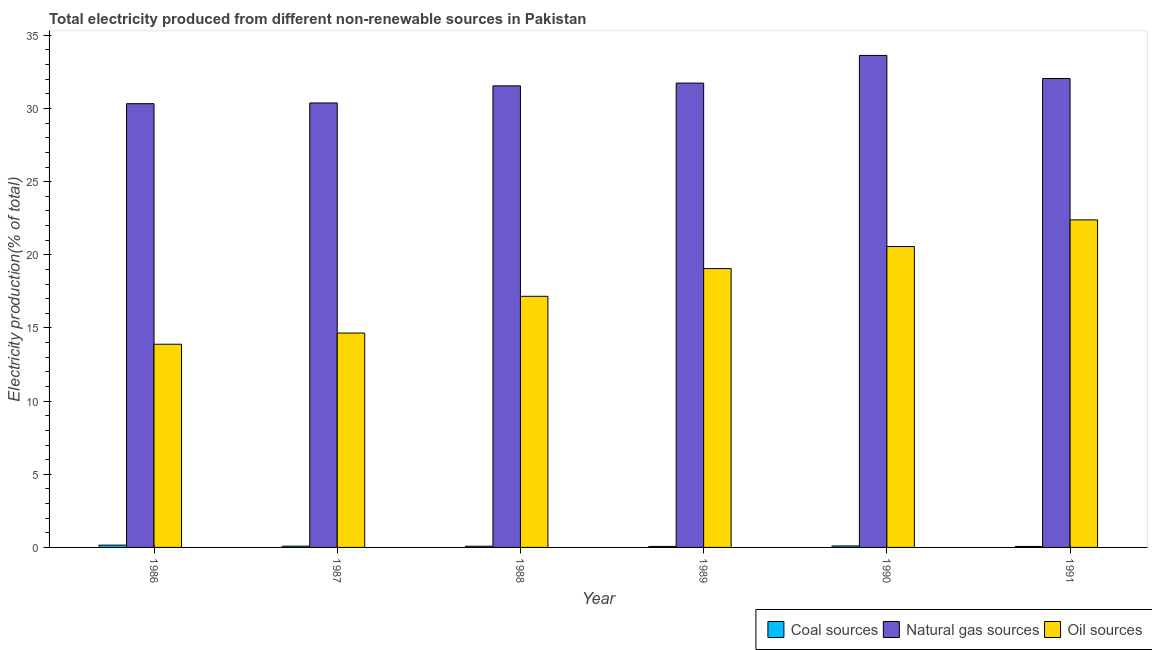How many bars are there on the 4th tick from the right?
Your answer should be compact. 3. What is the percentage of electricity produced by coal in 1988?
Your answer should be very brief. 0.08. Across all years, what is the maximum percentage of electricity produced by oil sources?
Your response must be concise. 22.39. Across all years, what is the minimum percentage of electricity produced by coal?
Your response must be concise. 0.07. In which year was the percentage of electricity produced by natural gas minimum?
Offer a very short reply. 1986. What is the total percentage of electricity produced by oil sources in the graph?
Offer a terse response. 107.72. What is the difference between the percentage of electricity produced by oil sources in 1986 and that in 1988?
Make the answer very short. -3.28. What is the difference between the percentage of electricity produced by coal in 1991 and the percentage of electricity produced by oil sources in 1990?
Offer a terse response. -0.04. What is the average percentage of electricity produced by oil sources per year?
Your answer should be compact. 17.95. What is the ratio of the percentage of electricity produced by natural gas in 1987 to that in 1988?
Provide a succinct answer. 0.96. What is the difference between the highest and the second highest percentage of electricity produced by coal?
Offer a terse response. 0.06. What is the difference between the highest and the lowest percentage of electricity produced by oil sources?
Your response must be concise. 8.5. In how many years, is the percentage of electricity produced by oil sources greater than the average percentage of electricity produced by oil sources taken over all years?
Keep it short and to the point. 3. What does the 2nd bar from the left in 1989 represents?
Provide a succinct answer. Natural gas sources. What does the 3rd bar from the right in 1989 represents?
Provide a succinct answer. Coal sources. How many bars are there?
Make the answer very short. 18. Are the values on the major ticks of Y-axis written in scientific E-notation?
Your response must be concise. No. Where does the legend appear in the graph?
Make the answer very short. Bottom right. What is the title of the graph?
Give a very brief answer. Total electricity produced from different non-renewable sources in Pakistan. What is the label or title of the Y-axis?
Offer a very short reply. Electricity production(% of total). What is the Electricity production(% of total) in Coal sources in 1986?
Your answer should be very brief. 0.16. What is the Electricity production(% of total) of Natural gas sources in 1986?
Provide a succinct answer. 30.33. What is the Electricity production(% of total) of Oil sources in 1986?
Offer a terse response. 13.89. What is the Electricity production(% of total) in Coal sources in 1987?
Your answer should be compact. 0.09. What is the Electricity production(% of total) in Natural gas sources in 1987?
Your answer should be compact. 30.38. What is the Electricity production(% of total) of Oil sources in 1987?
Ensure brevity in your answer.  14.65. What is the Electricity production(% of total) in Coal sources in 1988?
Offer a terse response. 0.08. What is the Electricity production(% of total) of Natural gas sources in 1988?
Your response must be concise. 31.55. What is the Electricity production(% of total) of Oil sources in 1988?
Your answer should be compact. 17.16. What is the Electricity production(% of total) in Coal sources in 1989?
Offer a very short reply. 0.07. What is the Electricity production(% of total) in Natural gas sources in 1989?
Ensure brevity in your answer.  31.74. What is the Electricity production(% of total) of Oil sources in 1989?
Keep it short and to the point. 19.06. What is the Electricity production(% of total) in Coal sources in 1990?
Make the answer very short. 0.1. What is the Electricity production(% of total) in Natural gas sources in 1990?
Keep it short and to the point. 33.63. What is the Electricity production(% of total) in Oil sources in 1990?
Make the answer very short. 20.57. What is the Electricity production(% of total) of Coal sources in 1991?
Your answer should be very brief. 0.07. What is the Electricity production(% of total) in Natural gas sources in 1991?
Offer a terse response. 32.05. What is the Electricity production(% of total) of Oil sources in 1991?
Offer a very short reply. 22.39. Across all years, what is the maximum Electricity production(% of total) in Coal sources?
Give a very brief answer. 0.16. Across all years, what is the maximum Electricity production(% of total) of Natural gas sources?
Provide a short and direct response. 33.63. Across all years, what is the maximum Electricity production(% of total) of Oil sources?
Your answer should be compact. 22.39. Across all years, what is the minimum Electricity production(% of total) in Coal sources?
Offer a very short reply. 0.07. Across all years, what is the minimum Electricity production(% of total) in Natural gas sources?
Offer a very short reply. 30.33. Across all years, what is the minimum Electricity production(% of total) of Oil sources?
Ensure brevity in your answer.  13.89. What is the total Electricity production(% of total) in Coal sources in the graph?
Provide a short and direct response. 0.56. What is the total Electricity production(% of total) in Natural gas sources in the graph?
Your response must be concise. 189.68. What is the total Electricity production(% of total) in Oil sources in the graph?
Your answer should be very brief. 107.72. What is the difference between the Electricity production(% of total) in Coal sources in 1986 and that in 1987?
Offer a terse response. 0.07. What is the difference between the Electricity production(% of total) of Natural gas sources in 1986 and that in 1987?
Your answer should be compact. -0.05. What is the difference between the Electricity production(% of total) of Oil sources in 1986 and that in 1987?
Make the answer very short. -0.76. What is the difference between the Electricity production(% of total) in Coal sources in 1986 and that in 1988?
Your response must be concise. 0.07. What is the difference between the Electricity production(% of total) in Natural gas sources in 1986 and that in 1988?
Your answer should be very brief. -1.22. What is the difference between the Electricity production(% of total) of Oil sources in 1986 and that in 1988?
Offer a very short reply. -3.28. What is the difference between the Electricity production(% of total) of Coal sources in 1986 and that in 1989?
Offer a very short reply. 0.09. What is the difference between the Electricity production(% of total) of Natural gas sources in 1986 and that in 1989?
Ensure brevity in your answer.  -1.41. What is the difference between the Electricity production(% of total) in Oil sources in 1986 and that in 1989?
Give a very brief answer. -5.17. What is the difference between the Electricity production(% of total) of Coal sources in 1986 and that in 1990?
Provide a succinct answer. 0.06. What is the difference between the Electricity production(% of total) in Natural gas sources in 1986 and that in 1990?
Provide a succinct answer. -3.3. What is the difference between the Electricity production(% of total) in Oil sources in 1986 and that in 1990?
Your answer should be compact. -6.68. What is the difference between the Electricity production(% of total) in Coal sources in 1986 and that in 1991?
Your answer should be compact. 0.09. What is the difference between the Electricity production(% of total) of Natural gas sources in 1986 and that in 1991?
Offer a terse response. -1.72. What is the difference between the Electricity production(% of total) in Oil sources in 1986 and that in 1991?
Give a very brief answer. -8.5. What is the difference between the Electricity production(% of total) in Coal sources in 1987 and that in 1988?
Ensure brevity in your answer.  0.01. What is the difference between the Electricity production(% of total) of Natural gas sources in 1987 and that in 1988?
Give a very brief answer. -1.17. What is the difference between the Electricity production(% of total) in Oil sources in 1987 and that in 1988?
Your answer should be compact. -2.51. What is the difference between the Electricity production(% of total) of Coal sources in 1987 and that in 1989?
Offer a very short reply. 0.02. What is the difference between the Electricity production(% of total) in Natural gas sources in 1987 and that in 1989?
Keep it short and to the point. -1.36. What is the difference between the Electricity production(% of total) of Oil sources in 1987 and that in 1989?
Keep it short and to the point. -4.41. What is the difference between the Electricity production(% of total) in Coal sources in 1987 and that in 1990?
Provide a succinct answer. -0.01. What is the difference between the Electricity production(% of total) in Natural gas sources in 1987 and that in 1990?
Ensure brevity in your answer.  -3.25. What is the difference between the Electricity production(% of total) in Oil sources in 1987 and that in 1990?
Provide a succinct answer. -5.91. What is the difference between the Electricity production(% of total) in Coal sources in 1987 and that in 1991?
Give a very brief answer. 0.02. What is the difference between the Electricity production(% of total) of Natural gas sources in 1987 and that in 1991?
Offer a terse response. -1.67. What is the difference between the Electricity production(% of total) in Oil sources in 1987 and that in 1991?
Provide a short and direct response. -7.73. What is the difference between the Electricity production(% of total) in Coal sources in 1988 and that in 1989?
Offer a very short reply. 0.01. What is the difference between the Electricity production(% of total) of Natural gas sources in 1988 and that in 1989?
Your answer should be compact. -0.19. What is the difference between the Electricity production(% of total) of Oil sources in 1988 and that in 1989?
Your answer should be very brief. -1.9. What is the difference between the Electricity production(% of total) in Coal sources in 1988 and that in 1990?
Offer a terse response. -0.02. What is the difference between the Electricity production(% of total) in Natural gas sources in 1988 and that in 1990?
Provide a succinct answer. -2.08. What is the difference between the Electricity production(% of total) in Oil sources in 1988 and that in 1990?
Keep it short and to the point. -3.4. What is the difference between the Electricity production(% of total) in Coal sources in 1988 and that in 1991?
Make the answer very short. 0.02. What is the difference between the Electricity production(% of total) of Natural gas sources in 1988 and that in 1991?
Provide a short and direct response. -0.5. What is the difference between the Electricity production(% of total) of Oil sources in 1988 and that in 1991?
Offer a very short reply. -5.22. What is the difference between the Electricity production(% of total) in Coal sources in 1989 and that in 1990?
Ensure brevity in your answer.  -0.03. What is the difference between the Electricity production(% of total) in Natural gas sources in 1989 and that in 1990?
Offer a very short reply. -1.89. What is the difference between the Electricity production(% of total) of Oil sources in 1989 and that in 1990?
Keep it short and to the point. -1.51. What is the difference between the Electricity production(% of total) in Coal sources in 1989 and that in 1991?
Provide a succinct answer. 0. What is the difference between the Electricity production(% of total) in Natural gas sources in 1989 and that in 1991?
Offer a very short reply. -0.31. What is the difference between the Electricity production(% of total) in Oil sources in 1989 and that in 1991?
Keep it short and to the point. -3.33. What is the difference between the Electricity production(% of total) in Coal sources in 1990 and that in 1991?
Make the answer very short. 0.04. What is the difference between the Electricity production(% of total) in Natural gas sources in 1990 and that in 1991?
Keep it short and to the point. 1.58. What is the difference between the Electricity production(% of total) of Oil sources in 1990 and that in 1991?
Your response must be concise. -1.82. What is the difference between the Electricity production(% of total) in Coal sources in 1986 and the Electricity production(% of total) in Natural gas sources in 1987?
Your answer should be very brief. -30.22. What is the difference between the Electricity production(% of total) in Coal sources in 1986 and the Electricity production(% of total) in Oil sources in 1987?
Give a very brief answer. -14.5. What is the difference between the Electricity production(% of total) in Natural gas sources in 1986 and the Electricity production(% of total) in Oil sources in 1987?
Keep it short and to the point. 15.68. What is the difference between the Electricity production(% of total) in Coal sources in 1986 and the Electricity production(% of total) in Natural gas sources in 1988?
Your answer should be very brief. -31.39. What is the difference between the Electricity production(% of total) of Coal sources in 1986 and the Electricity production(% of total) of Oil sources in 1988?
Ensure brevity in your answer.  -17.01. What is the difference between the Electricity production(% of total) of Natural gas sources in 1986 and the Electricity production(% of total) of Oil sources in 1988?
Provide a succinct answer. 13.16. What is the difference between the Electricity production(% of total) of Coal sources in 1986 and the Electricity production(% of total) of Natural gas sources in 1989?
Your answer should be very brief. -31.58. What is the difference between the Electricity production(% of total) in Coal sources in 1986 and the Electricity production(% of total) in Oil sources in 1989?
Your response must be concise. -18.9. What is the difference between the Electricity production(% of total) of Natural gas sources in 1986 and the Electricity production(% of total) of Oil sources in 1989?
Ensure brevity in your answer.  11.27. What is the difference between the Electricity production(% of total) in Coal sources in 1986 and the Electricity production(% of total) in Natural gas sources in 1990?
Your answer should be compact. -33.47. What is the difference between the Electricity production(% of total) in Coal sources in 1986 and the Electricity production(% of total) in Oil sources in 1990?
Give a very brief answer. -20.41. What is the difference between the Electricity production(% of total) in Natural gas sources in 1986 and the Electricity production(% of total) in Oil sources in 1990?
Keep it short and to the point. 9.76. What is the difference between the Electricity production(% of total) in Coal sources in 1986 and the Electricity production(% of total) in Natural gas sources in 1991?
Keep it short and to the point. -31.89. What is the difference between the Electricity production(% of total) of Coal sources in 1986 and the Electricity production(% of total) of Oil sources in 1991?
Provide a succinct answer. -22.23. What is the difference between the Electricity production(% of total) in Natural gas sources in 1986 and the Electricity production(% of total) in Oil sources in 1991?
Keep it short and to the point. 7.94. What is the difference between the Electricity production(% of total) in Coal sources in 1987 and the Electricity production(% of total) in Natural gas sources in 1988?
Your answer should be compact. -31.46. What is the difference between the Electricity production(% of total) in Coal sources in 1987 and the Electricity production(% of total) in Oil sources in 1988?
Provide a short and direct response. -17.08. What is the difference between the Electricity production(% of total) in Natural gas sources in 1987 and the Electricity production(% of total) in Oil sources in 1988?
Keep it short and to the point. 13.22. What is the difference between the Electricity production(% of total) of Coal sources in 1987 and the Electricity production(% of total) of Natural gas sources in 1989?
Provide a succinct answer. -31.65. What is the difference between the Electricity production(% of total) in Coal sources in 1987 and the Electricity production(% of total) in Oil sources in 1989?
Your response must be concise. -18.97. What is the difference between the Electricity production(% of total) in Natural gas sources in 1987 and the Electricity production(% of total) in Oil sources in 1989?
Provide a succinct answer. 11.32. What is the difference between the Electricity production(% of total) in Coal sources in 1987 and the Electricity production(% of total) in Natural gas sources in 1990?
Provide a short and direct response. -33.54. What is the difference between the Electricity production(% of total) of Coal sources in 1987 and the Electricity production(% of total) of Oil sources in 1990?
Offer a very short reply. -20.48. What is the difference between the Electricity production(% of total) in Natural gas sources in 1987 and the Electricity production(% of total) in Oil sources in 1990?
Offer a terse response. 9.81. What is the difference between the Electricity production(% of total) of Coal sources in 1987 and the Electricity production(% of total) of Natural gas sources in 1991?
Offer a terse response. -31.96. What is the difference between the Electricity production(% of total) in Coal sources in 1987 and the Electricity production(% of total) in Oil sources in 1991?
Make the answer very short. -22.3. What is the difference between the Electricity production(% of total) of Natural gas sources in 1987 and the Electricity production(% of total) of Oil sources in 1991?
Offer a very short reply. 7.99. What is the difference between the Electricity production(% of total) in Coal sources in 1988 and the Electricity production(% of total) in Natural gas sources in 1989?
Your answer should be very brief. -31.66. What is the difference between the Electricity production(% of total) of Coal sources in 1988 and the Electricity production(% of total) of Oil sources in 1989?
Keep it short and to the point. -18.98. What is the difference between the Electricity production(% of total) in Natural gas sources in 1988 and the Electricity production(% of total) in Oil sources in 1989?
Offer a terse response. 12.49. What is the difference between the Electricity production(% of total) in Coal sources in 1988 and the Electricity production(% of total) in Natural gas sources in 1990?
Keep it short and to the point. -33.55. What is the difference between the Electricity production(% of total) in Coal sources in 1988 and the Electricity production(% of total) in Oil sources in 1990?
Ensure brevity in your answer.  -20.48. What is the difference between the Electricity production(% of total) in Natural gas sources in 1988 and the Electricity production(% of total) in Oil sources in 1990?
Provide a short and direct response. 10.98. What is the difference between the Electricity production(% of total) in Coal sources in 1988 and the Electricity production(% of total) in Natural gas sources in 1991?
Your answer should be compact. -31.97. What is the difference between the Electricity production(% of total) in Coal sources in 1988 and the Electricity production(% of total) in Oil sources in 1991?
Your answer should be very brief. -22.31. What is the difference between the Electricity production(% of total) in Natural gas sources in 1988 and the Electricity production(% of total) in Oil sources in 1991?
Provide a short and direct response. 9.16. What is the difference between the Electricity production(% of total) in Coal sources in 1989 and the Electricity production(% of total) in Natural gas sources in 1990?
Your answer should be compact. -33.56. What is the difference between the Electricity production(% of total) in Coal sources in 1989 and the Electricity production(% of total) in Oil sources in 1990?
Give a very brief answer. -20.5. What is the difference between the Electricity production(% of total) in Natural gas sources in 1989 and the Electricity production(% of total) in Oil sources in 1990?
Keep it short and to the point. 11.17. What is the difference between the Electricity production(% of total) in Coal sources in 1989 and the Electricity production(% of total) in Natural gas sources in 1991?
Offer a terse response. -31.98. What is the difference between the Electricity production(% of total) of Coal sources in 1989 and the Electricity production(% of total) of Oil sources in 1991?
Your answer should be very brief. -22.32. What is the difference between the Electricity production(% of total) of Natural gas sources in 1989 and the Electricity production(% of total) of Oil sources in 1991?
Offer a terse response. 9.35. What is the difference between the Electricity production(% of total) of Coal sources in 1990 and the Electricity production(% of total) of Natural gas sources in 1991?
Ensure brevity in your answer.  -31.95. What is the difference between the Electricity production(% of total) in Coal sources in 1990 and the Electricity production(% of total) in Oil sources in 1991?
Offer a very short reply. -22.29. What is the difference between the Electricity production(% of total) of Natural gas sources in 1990 and the Electricity production(% of total) of Oil sources in 1991?
Offer a terse response. 11.24. What is the average Electricity production(% of total) in Coal sources per year?
Give a very brief answer. 0.09. What is the average Electricity production(% of total) in Natural gas sources per year?
Provide a succinct answer. 31.61. What is the average Electricity production(% of total) of Oil sources per year?
Your answer should be compact. 17.95. In the year 1986, what is the difference between the Electricity production(% of total) of Coal sources and Electricity production(% of total) of Natural gas sources?
Keep it short and to the point. -30.17. In the year 1986, what is the difference between the Electricity production(% of total) in Coal sources and Electricity production(% of total) in Oil sources?
Offer a terse response. -13.73. In the year 1986, what is the difference between the Electricity production(% of total) of Natural gas sources and Electricity production(% of total) of Oil sources?
Provide a short and direct response. 16.44. In the year 1987, what is the difference between the Electricity production(% of total) of Coal sources and Electricity production(% of total) of Natural gas sources?
Your response must be concise. -30.29. In the year 1987, what is the difference between the Electricity production(% of total) in Coal sources and Electricity production(% of total) in Oil sources?
Your response must be concise. -14.57. In the year 1987, what is the difference between the Electricity production(% of total) of Natural gas sources and Electricity production(% of total) of Oil sources?
Your response must be concise. 15.73. In the year 1988, what is the difference between the Electricity production(% of total) in Coal sources and Electricity production(% of total) in Natural gas sources?
Offer a very short reply. -31.47. In the year 1988, what is the difference between the Electricity production(% of total) of Coal sources and Electricity production(% of total) of Oil sources?
Your answer should be very brief. -17.08. In the year 1988, what is the difference between the Electricity production(% of total) in Natural gas sources and Electricity production(% of total) in Oil sources?
Your answer should be very brief. 14.38. In the year 1989, what is the difference between the Electricity production(% of total) of Coal sources and Electricity production(% of total) of Natural gas sources?
Give a very brief answer. -31.67. In the year 1989, what is the difference between the Electricity production(% of total) of Coal sources and Electricity production(% of total) of Oil sources?
Offer a very short reply. -18.99. In the year 1989, what is the difference between the Electricity production(% of total) of Natural gas sources and Electricity production(% of total) of Oil sources?
Offer a terse response. 12.68. In the year 1990, what is the difference between the Electricity production(% of total) of Coal sources and Electricity production(% of total) of Natural gas sources?
Give a very brief answer. -33.53. In the year 1990, what is the difference between the Electricity production(% of total) of Coal sources and Electricity production(% of total) of Oil sources?
Ensure brevity in your answer.  -20.47. In the year 1990, what is the difference between the Electricity production(% of total) of Natural gas sources and Electricity production(% of total) of Oil sources?
Offer a very short reply. 13.06. In the year 1991, what is the difference between the Electricity production(% of total) in Coal sources and Electricity production(% of total) in Natural gas sources?
Offer a very short reply. -31.98. In the year 1991, what is the difference between the Electricity production(% of total) of Coal sources and Electricity production(% of total) of Oil sources?
Keep it short and to the point. -22.32. In the year 1991, what is the difference between the Electricity production(% of total) of Natural gas sources and Electricity production(% of total) of Oil sources?
Provide a short and direct response. 9.66. What is the ratio of the Electricity production(% of total) in Coal sources in 1986 to that in 1987?
Give a very brief answer. 1.79. What is the ratio of the Electricity production(% of total) of Natural gas sources in 1986 to that in 1987?
Your answer should be very brief. 1. What is the ratio of the Electricity production(% of total) in Oil sources in 1986 to that in 1987?
Your answer should be very brief. 0.95. What is the ratio of the Electricity production(% of total) in Coal sources in 1986 to that in 1988?
Your answer should be very brief. 1.92. What is the ratio of the Electricity production(% of total) in Natural gas sources in 1986 to that in 1988?
Offer a terse response. 0.96. What is the ratio of the Electricity production(% of total) of Oil sources in 1986 to that in 1988?
Make the answer very short. 0.81. What is the ratio of the Electricity production(% of total) in Coal sources in 1986 to that in 1989?
Your response must be concise. 2.25. What is the ratio of the Electricity production(% of total) in Natural gas sources in 1986 to that in 1989?
Provide a short and direct response. 0.96. What is the ratio of the Electricity production(% of total) of Oil sources in 1986 to that in 1989?
Provide a short and direct response. 0.73. What is the ratio of the Electricity production(% of total) in Coal sources in 1986 to that in 1990?
Your answer should be very brief. 1.55. What is the ratio of the Electricity production(% of total) of Natural gas sources in 1986 to that in 1990?
Offer a very short reply. 0.9. What is the ratio of the Electricity production(% of total) in Oil sources in 1986 to that in 1990?
Offer a very short reply. 0.68. What is the ratio of the Electricity production(% of total) in Coal sources in 1986 to that in 1991?
Offer a terse response. 2.38. What is the ratio of the Electricity production(% of total) of Natural gas sources in 1986 to that in 1991?
Provide a short and direct response. 0.95. What is the ratio of the Electricity production(% of total) of Oil sources in 1986 to that in 1991?
Offer a very short reply. 0.62. What is the ratio of the Electricity production(% of total) of Coal sources in 1987 to that in 1988?
Offer a very short reply. 1.07. What is the ratio of the Electricity production(% of total) in Natural gas sources in 1987 to that in 1988?
Ensure brevity in your answer.  0.96. What is the ratio of the Electricity production(% of total) of Oil sources in 1987 to that in 1988?
Give a very brief answer. 0.85. What is the ratio of the Electricity production(% of total) in Coal sources in 1987 to that in 1989?
Provide a succinct answer. 1.26. What is the ratio of the Electricity production(% of total) in Natural gas sources in 1987 to that in 1989?
Give a very brief answer. 0.96. What is the ratio of the Electricity production(% of total) of Oil sources in 1987 to that in 1989?
Your response must be concise. 0.77. What is the ratio of the Electricity production(% of total) of Coal sources in 1987 to that in 1990?
Your response must be concise. 0.86. What is the ratio of the Electricity production(% of total) of Natural gas sources in 1987 to that in 1990?
Ensure brevity in your answer.  0.9. What is the ratio of the Electricity production(% of total) in Oil sources in 1987 to that in 1990?
Give a very brief answer. 0.71. What is the ratio of the Electricity production(% of total) of Coal sources in 1987 to that in 1991?
Ensure brevity in your answer.  1.33. What is the ratio of the Electricity production(% of total) of Natural gas sources in 1987 to that in 1991?
Make the answer very short. 0.95. What is the ratio of the Electricity production(% of total) in Oil sources in 1987 to that in 1991?
Make the answer very short. 0.65. What is the ratio of the Electricity production(% of total) in Coal sources in 1988 to that in 1989?
Offer a terse response. 1.18. What is the ratio of the Electricity production(% of total) in Natural gas sources in 1988 to that in 1989?
Keep it short and to the point. 0.99. What is the ratio of the Electricity production(% of total) of Oil sources in 1988 to that in 1989?
Offer a very short reply. 0.9. What is the ratio of the Electricity production(% of total) of Coal sources in 1988 to that in 1990?
Provide a short and direct response. 0.81. What is the ratio of the Electricity production(% of total) of Natural gas sources in 1988 to that in 1990?
Your answer should be compact. 0.94. What is the ratio of the Electricity production(% of total) of Oil sources in 1988 to that in 1990?
Ensure brevity in your answer.  0.83. What is the ratio of the Electricity production(% of total) of Coal sources in 1988 to that in 1991?
Provide a succinct answer. 1.24. What is the ratio of the Electricity production(% of total) of Natural gas sources in 1988 to that in 1991?
Offer a terse response. 0.98. What is the ratio of the Electricity production(% of total) of Oil sources in 1988 to that in 1991?
Provide a succinct answer. 0.77. What is the ratio of the Electricity production(% of total) in Coal sources in 1989 to that in 1990?
Keep it short and to the point. 0.69. What is the ratio of the Electricity production(% of total) of Natural gas sources in 1989 to that in 1990?
Provide a short and direct response. 0.94. What is the ratio of the Electricity production(% of total) of Oil sources in 1989 to that in 1990?
Offer a terse response. 0.93. What is the ratio of the Electricity production(% of total) of Coal sources in 1989 to that in 1991?
Ensure brevity in your answer.  1.06. What is the ratio of the Electricity production(% of total) of Natural gas sources in 1989 to that in 1991?
Ensure brevity in your answer.  0.99. What is the ratio of the Electricity production(% of total) of Oil sources in 1989 to that in 1991?
Provide a succinct answer. 0.85. What is the ratio of the Electricity production(% of total) of Coal sources in 1990 to that in 1991?
Provide a short and direct response. 1.53. What is the ratio of the Electricity production(% of total) of Natural gas sources in 1990 to that in 1991?
Make the answer very short. 1.05. What is the ratio of the Electricity production(% of total) in Oil sources in 1990 to that in 1991?
Ensure brevity in your answer.  0.92. What is the difference between the highest and the second highest Electricity production(% of total) of Coal sources?
Provide a short and direct response. 0.06. What is the difference between the highest and the second highest Electricity production(% of total) in Natural gas sources?
Your response must be concise. 1.58. What is the difference between the highest and the second highest Electricity production(% of total) in Oil sources?
Your answer should be very brief. 1.82. What is the difference between the highest and the lowest Electricity production(% of total) of Coal sources?
Make the answer very short. 0.09. What is the difference between the highest and the lowest Electricity production(% of total) of Natural gas sources?
Offer a very short reply. 3.3. What is the difference between the highest and the lowest Electricity production(% of total) in Oil sources?
Your response must be concise. 8.5. 